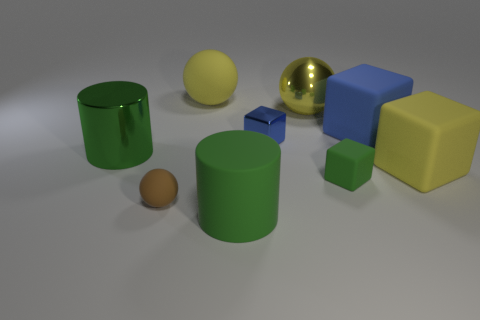Subtract all big spheres. How many spheres are left? 1 Subtract all blue cubes. How many cubes are left? 2 Subtract all blocks. How many objects are left? 5 Subtract 3 cubes. How many cubes are left? 1 Subtract all gray balls. Subtract all yellow cylinders. How many balls are left? 3 Subtract all yellow blocks. How many brown balls are left? 1 Subtract all brown matte balls. Subtract all blue metal blocks. How many objects are left? 7 Add 4 yellow rubber balls. How many yellow rubber balls are left? 5 Add 8 big spheres. How many big spheres exist? 10 Subtract 1 green cubes. How many objects are left? 8 